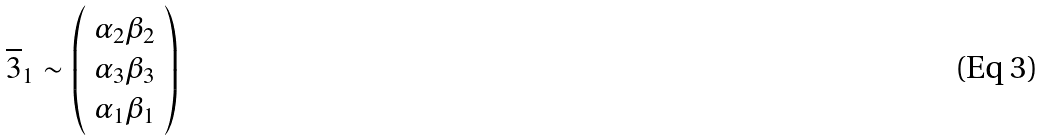Convert formula to latex. <formula><loc_0><loc_0><loc_500><loc_500>\overline { 3 } _ { 1 } \sim \left ( \begin{array} { c } \alpha _ { 2 } \beta _ { 2 } \\ \alpha _ { 3 } \beta _ { 3 } \\ \alpha _ { 1 } \beta _ { 1 } \\ \end{array} \right )</formula> 